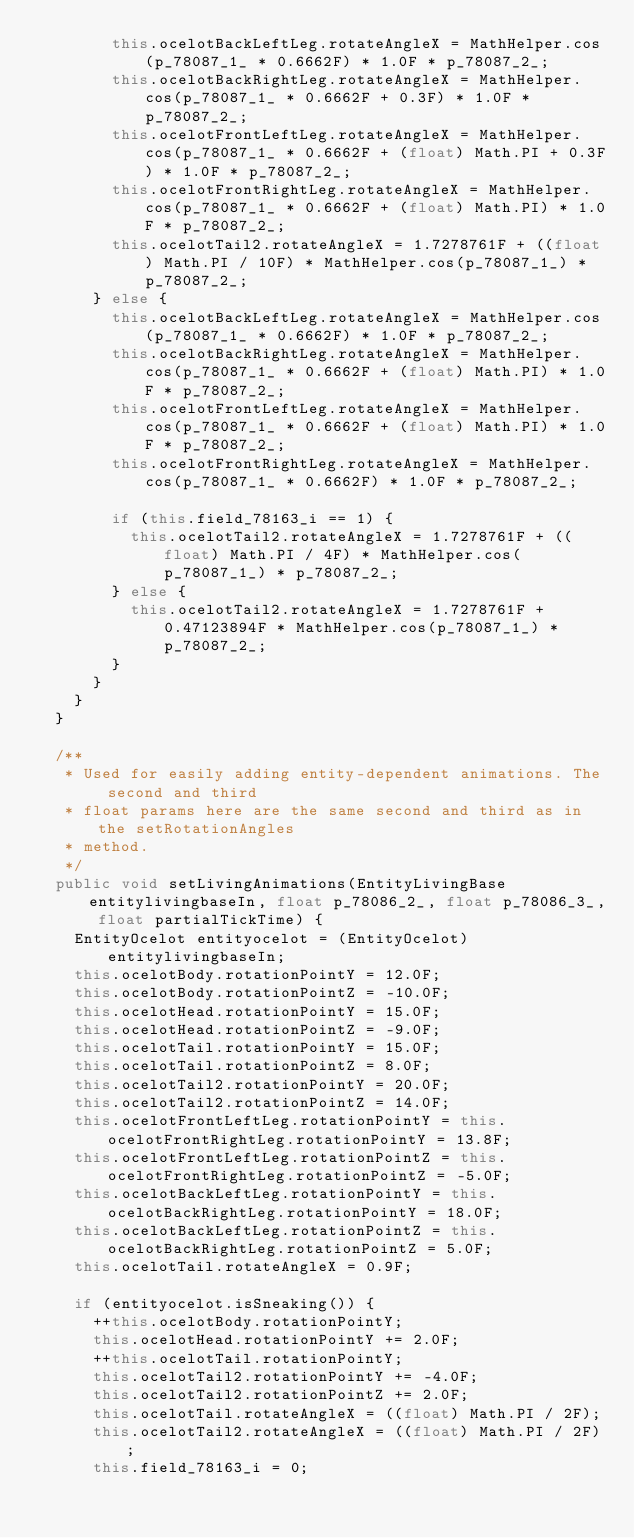Convert code to text. <code><loc_0><loc_0><loc_500><loc_500><_Java_>				this.ocelotBackLeftLeg.rotateAngleX = MathHelper.cos(p_78087_1_ * 0.6662F) * 1.0F * p_78087_2_;
				this.ocelotBackRightLeg.rotateAngleX = MathHelper.cos(p_78087_1_ * 0.6662F + 0.3F) * 1.0F * p_78087_2_;
				this.ocelotFrontLeftLeg.rotateAngleX = MathHelper.cos(p_78087_1_ * 0.6662F + (float) Math.PI + 0.3F) * 1.0F * p_78087_2_;
				this.ocelotFrontRightLeg.rotateAngleX = MathHelper.cos(p_78087_1_ * 0.6662F + (float) Math.PI) * 1.0F * p_78087_2_;
				this.ocelotTail2.rotateAngleX = 1.7278761F + ((float) Math.PI / 10F) * MathHelper.cos(p_78087_1_) * p_78087_2_;
			} else {
				this.ocelotBackLeftLeg.rotateAngleX = MathHelper.cos(p_78087_1_ * 0.6662F) * 1.0F * p_78087_2_;
				this.ocelotBackRightLeg.rotateAngleX = MathHelper.cos(p_78087_1_ * 0.6662F + (float) Math.PI) * 1.0F * p_78087_2_;
				this.ocelotFrontLeftLeg.rotateAngleX = MathHelper.cos(p_78087_1_ * 0.6662F + (float) Math.PI) * 1.0F * p_78087_2_;
				this.ocelotFrontRightLeg.rotateAngleX = MathHelper.cos(p_78087_1_ * 0.6662F) * 1.0F * p_78087_2_;

				if (this.field_78163_i == 1) {
					this.ocelotTail2.rotateAngleX = 1.7278761F + ((float) Math.PI / 4F) * MathHelper.cos(p_78087_1_) * p_78087_2_;
				} else {
					this.ocelotTail2.rotateAngleX = 1.7278761F + 0.47123894F * MathHelper.cos(p_78087_1_) * p_78087_2_;
				}
			}
		}
	}

	/**
	 * Used for easily adding entity-dependent animations. The second and third
	 * float params here are the same second and third as in the setRotationAngles
	 * method.
	 */
	public void setLivingAnimations(EntityLivingBase entitylivingbaseIn, float p_78086_2_, float p_78086_3_, float partialTickTime) {
		EntityOcelot entityocelot = (EntityOcelot) entitylivingbaseIn;
		this.ocelotBody.rotationPointY = 12.0F;
		this.ocelotBody.rotationPointZ = -10.0F;
		this.ocelotHead.rotationPointY = 15.0F;
		this.ocelotHead.rotationPointZ = -9.0F;
		this.ocelotTail.rotationPointY = 15.0F;
		this.ocelotTail.rotationPointZ = 8.0F;
		this.ocelotTail2.rotationPointY = 20.0F;
		this.ocelotTail2.rotationPointZ = 14.0F;
		this.ocelotFrontLeftLeg.rotationPointY = this.ocelotFrontRightLeg.rotationPointY = 13.8F;
		this.ocelotFrontLeftLeg.rotationPointZ = this.ocelotFrontRightLeg.rotationPointZ = -5.0F;
		this.ocelotBackLeftLeg.rotationPointY = this.ocelotBackRightLeg.rotationPointY = 18.0F;
		this.ocelotBackLeftLeg.rotationPointZ = this.ocelotBackRightLeg.rotationPointZ = 5.0F;
		this.ocelotTail.rotateAngleX = 0.9F;

		if (entityocelot.isSneaking()) {
			++this.ocelotBody.rotationPointY;
			this.ocelotHead.rotationPointY += 2.0F;
			++this.ocelotTail.rotationPointY;
			this.ocelotTail2.rotationPointY += -4.0F;
			this.ocelotTail2.rotationPointZ += 2.0F;
			this.ocelotTail.rotateAngleX = ((float) Math.PI / 2F);
			this.ocelotTail2.rotateAngleX = ((float) Math.PI / 2F);
			this.field_78163_i = 0;</code> 